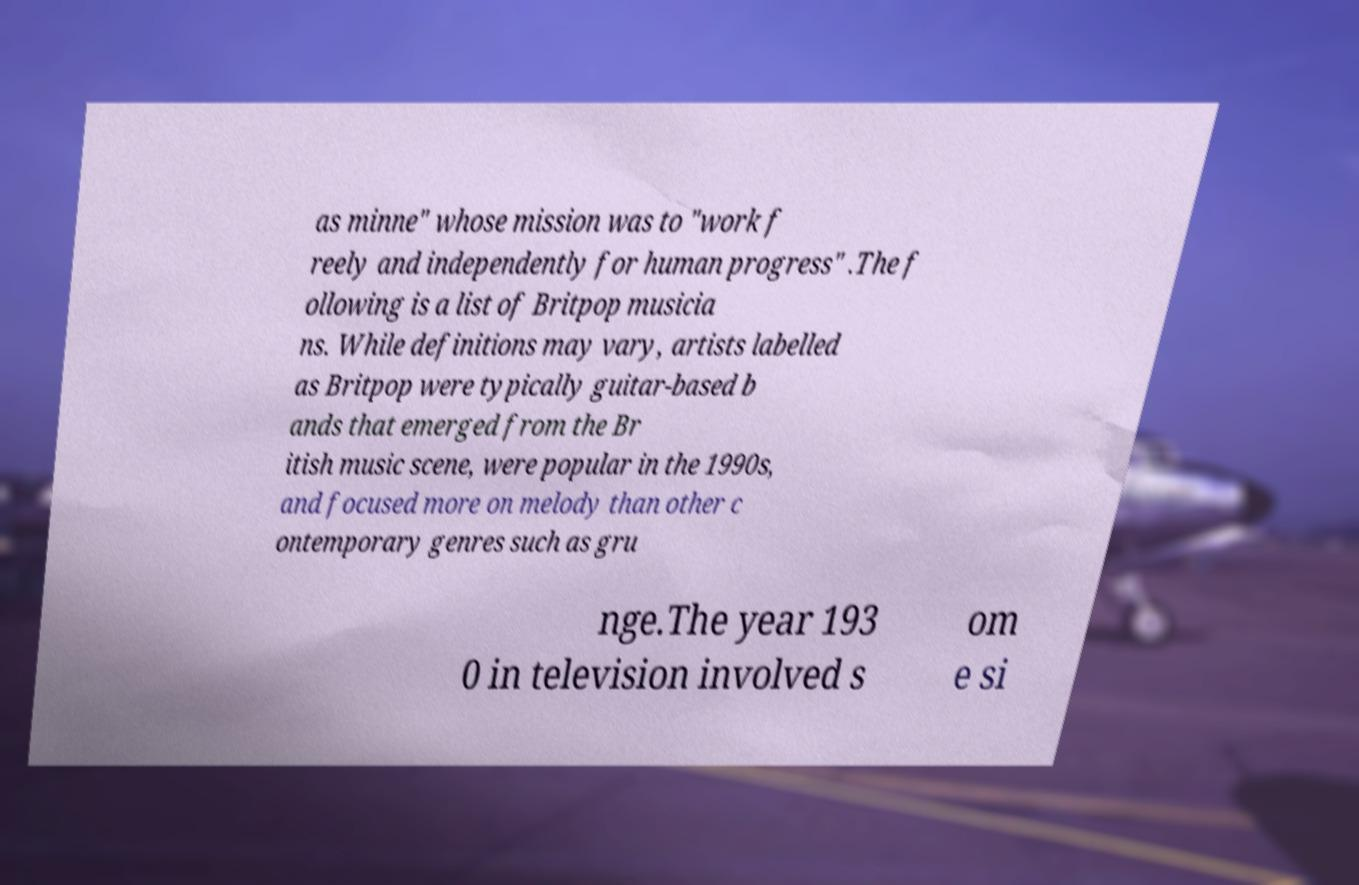Please identify and transcribe the text found in this image. as minne" whose mission was to "work f reely and independently for human progress" .The f ollowing is a list of Britpop musicia ns. While definitions may vary, artists labelled as Britpop were typically guitar-based b ands that emerged from the Br itish music scene, were popular in the 1990s, and focused more on melody than other c ontemporary genres such as gru nge.The year 193 0 in television involved s om e si 